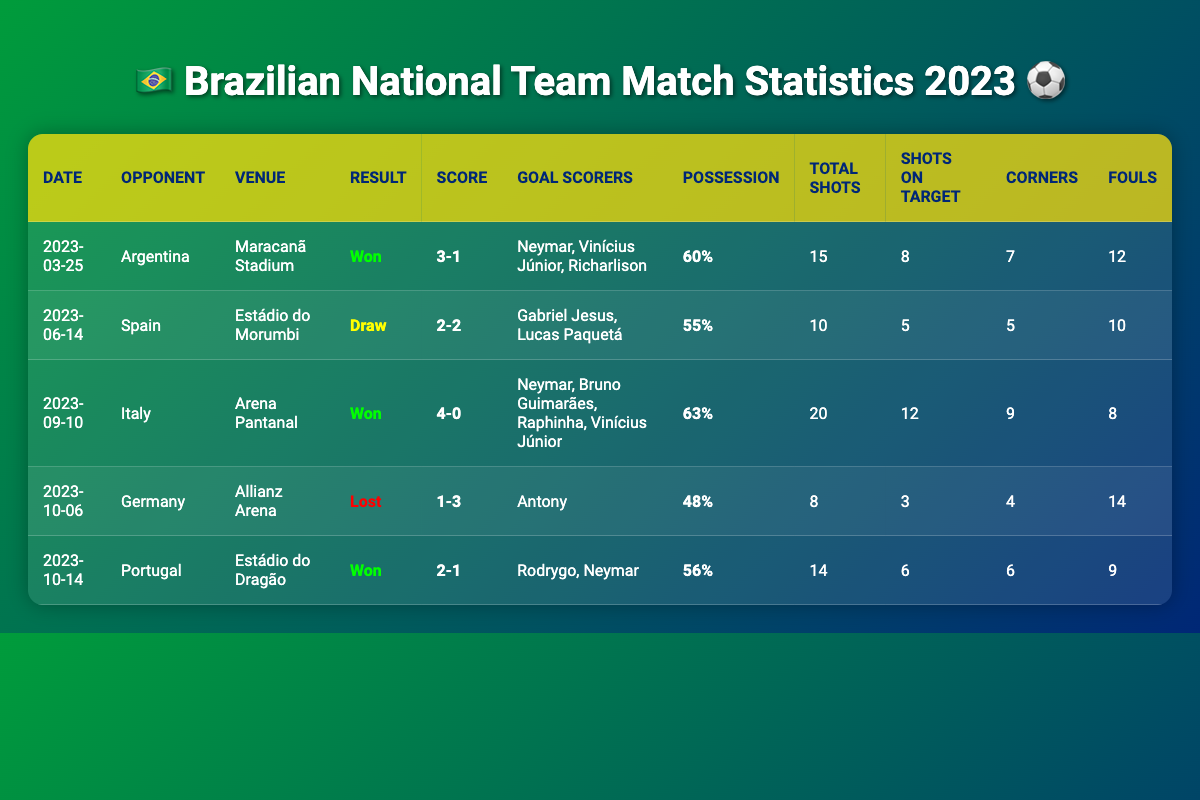What was the result of the match against Germany? The table shows the result of the match on 2023-10-06 against Germany in the "Result" column, which states "Lost."
Answer: Lost How many goals did Neymar score in the match against Italy? Looking at the match against Italy on 2023-09-10, the "Goals Scorers" column lists Neymar as one of the scorers, indicating he scored one goal in that match.
Answer: 1 Which match had the highest possession percentage, and what was that percentage? The match against Italy on 2023-09-10 had the highest possession percentage listed as 63%. By checking the "Possession" column for all entries, it's confirmed as the highest.
Answer: 63% Did Brazil score more goals against Argentina or Germany? Brazil scored 3 goals against Argentina (2023-03-25) and only 1 goal against Germany (2023-10-06). By comparing the "Score" column, it's clear they scored more against Argentina.
Answer: More against Argentina What is the average number of total shots taken in the matches that Brazil won? For the wins against Argentina, Italy, and Portugal, the total shots are 15, 20, and 14 respectively. Adding these gives 15 + 20 + 14 = 49. There are 3 matches, so averaging gives 49 / 3 = 16.33.
Answer: 16.33 How many goals did Brazil concede in the match against Portugal? The match against Portugal on 2023-10-14 ended with a score of 2-1. The goals conceded can be determined as 1 from the "Score" column.
Answer: 1 Was Brazil's possession higher in the draw against Spain than in the loss to Germany? The possession percentage in the draw against Spain (55%) and the loss to Germany (48%) shows that Brazil had higher possession in the match against Spain.
Answer: Yes How many total fouls were committed by Brazil in all their matches combined in 2023? By adding the total fouls for each match: 12 (Argentina) + 10 (Spain) + 8 (Italy) + 14 (Germany) + 9 (Portugal) gives 12 + 10 + 8 + 14 + 9 = 53.
Answer: 53 Which match had the highest number of shots on target? The match against Italy on 2023-09-10 had the highest shots on target listed as 12 in the "Shots on Target" column. By reviewing all matches, this is confirmed as the highest.
Answer: 12 How many different players scored for Brazil in the match against Argentina? The "Goals Scorers" column for the match against Argentina shows three players: Neymar, Vinícius Júnior, and Richarlison. Thus, three different players scored.
Answer: 3 What was Brazil's average score in matches they won? Brazil won three matches (Argentina 3-1, Italy 4-0, Portugal 2-1). By summing the scores: (3 + 1) + (4 + 0) + (2 + 1) = 11 goals scored and 3 goals conceded summing to 11-3 = 8. The winning average, calculating as follows, gives (11 goals / 3 matches) = 3.67.
Answer: 3.67 